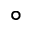<formula> <loc_0><loc_0><loc_500><loc_500>^ { \circ }</formula> 